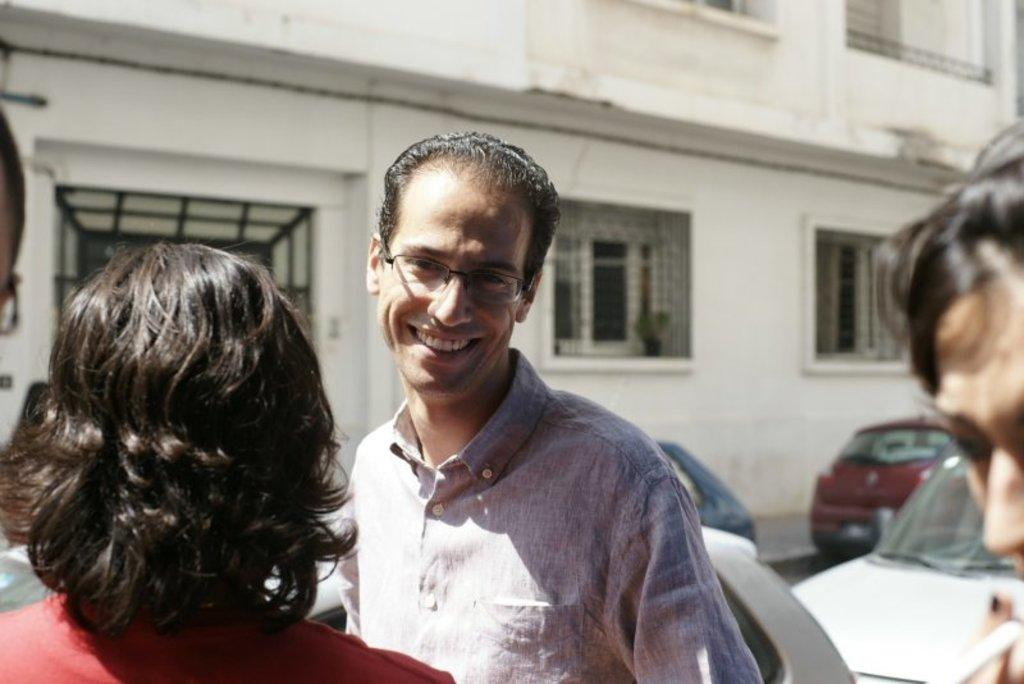What is happening in the image? There are people standing in the image. Can you describe any specific details about one of the people? One of the people is wearing glasses. What can be seen in the distance behind the people? There are vehicles and windows to a building visible in the background of the image. What type of frame is the bear holding in the image? There is no bear or frame present in the image. How many lines can be seen on the person wearing glasses in the image? The person wearing glasses does not have any visible lines on them in the image. 